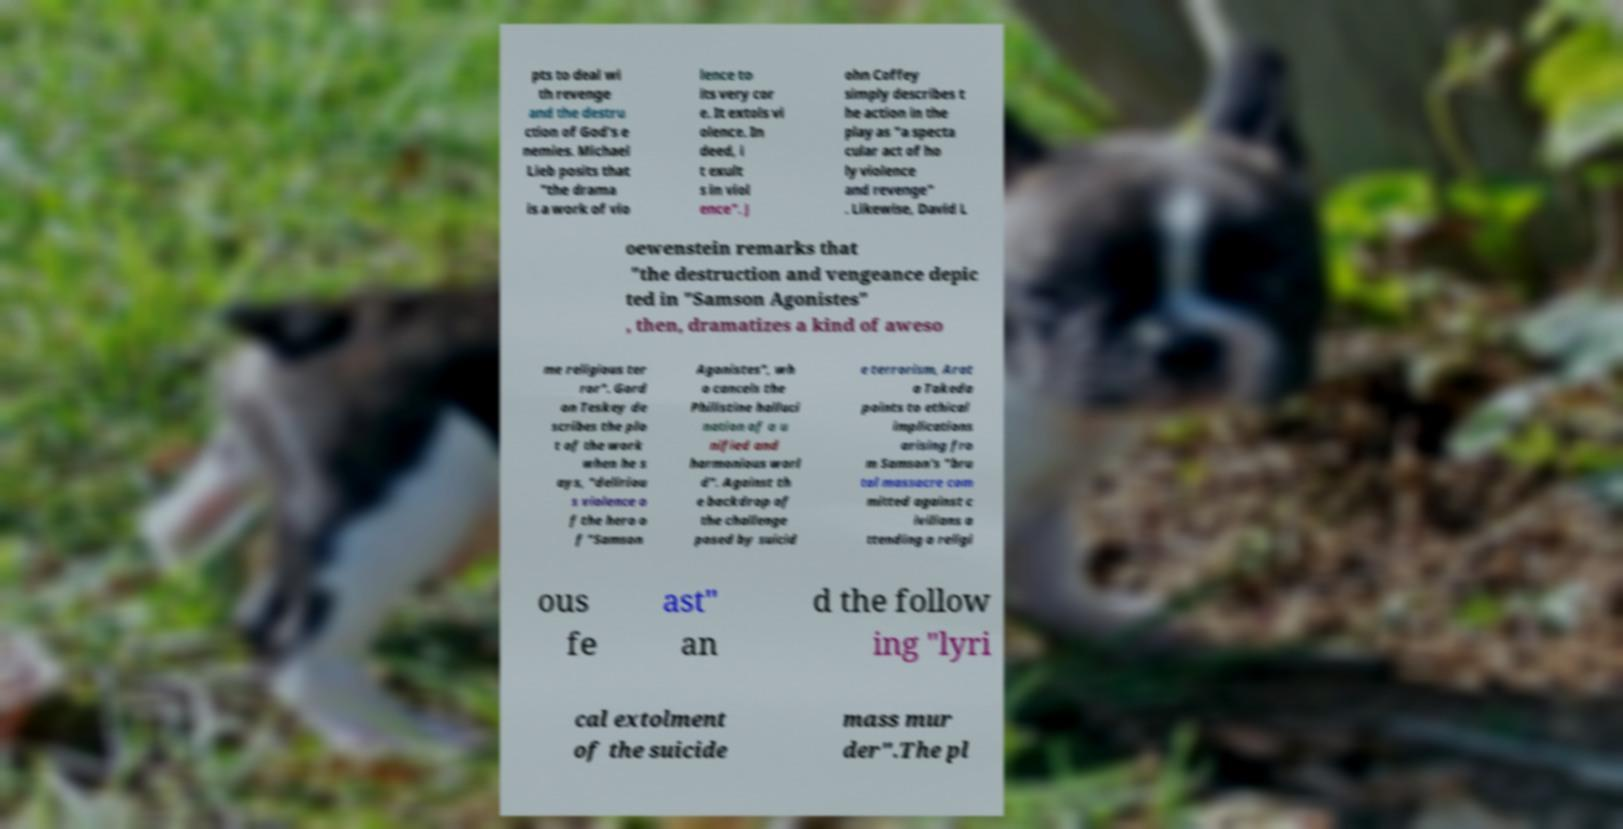For documentation purposes, I need the text within this image transcribed. Could you provide that? pts to deal wi th revenge and the destru ction of God's e nemies. Michael Lieb posits that "the drama is a work of vio lence to its very cor e. It extols vi olence. In deed, i t exult s in viol ence". J ohn Coffey simply describes t he action in the play as "a specta cular act of ho ly violence and revenge" . Likewise, David L oewenstein remarks that "the destruction and vengeance depic ted in "Samson Agonistes" , then, dramatizes a kind of aweso me religious ter ror". Gord on Teskey de scribes the plo t of the work when he s ays, "deliriou s violence o f the hero o f "Samson Agonistes", wh o cancels the Philistine halluci nation of a u nified and harmonious worl d". Against th e backdrop of the challenge posed by suicid e terrorism, Arat a Takeda points to ethical implications arising fro m Samson's "bru tal massacre com mitted against c ivilians a ttending a religi ous fe ast" an d the follow ing "lyri cal extolment of the suicide mass mur der".The pl 